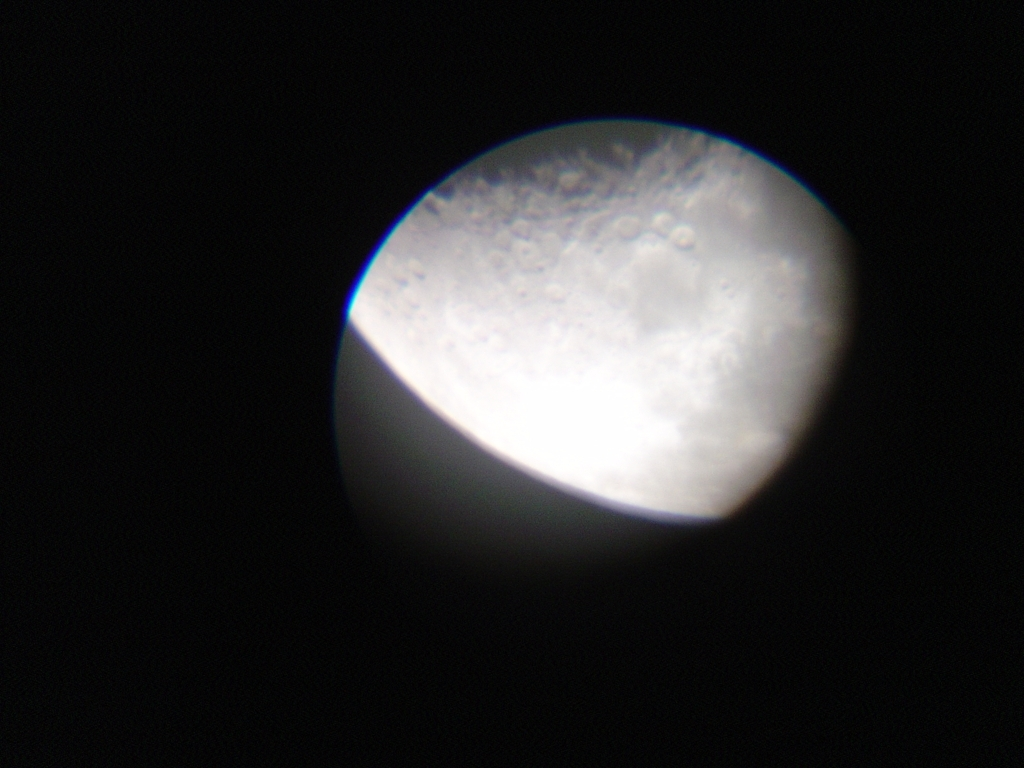Can you tell me more about what's captured in this image? The image appears to feature a magnified view of the Moon, showcasing craters and the lunar surface. The perspective suggests it might have been taken through a telescope or a camera with a zoom lens. The blue fringe is possibly chromatic aberration, a common optical issue in photography. Why does the Moon have so many craters? The Moon's surface is covered in craters due to billions of years of impacts from asteroids and comets. Unlike Earth, the Moon lacks an atmosphere to protect it from space debris, so these objects strike the surface directly, creating craters. 